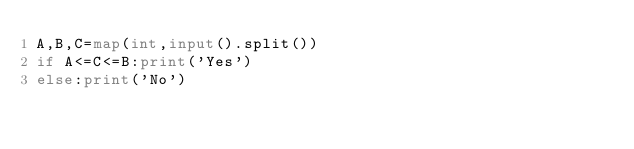Convert code to text. <code><loc_0><loc_0><loc_500><loc_500><_Python_>A,B,C=map(int,input().split())
if A<=C<=B:print('Yes')
else:print('No')</code> 